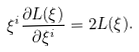Convert formula to latex. <formula><loc_0><loc_0><loc_500><loc_500>\xi ^ { i } \frac { \partial L ( \xi ) } { \partial \xi ^ { i } } = 2 L ( \xi ) .</formula> 